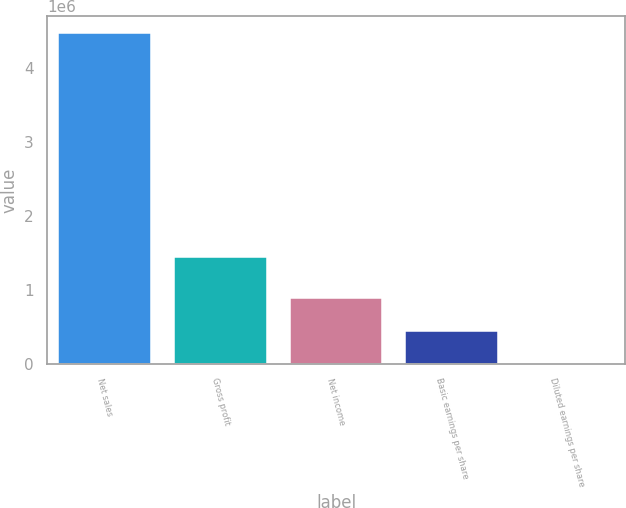Convert chart. <chart><loc_0><loc_0><loc_500><loc_500><bar_chart><fcel>Net sales<fcel>Gross profit<fcel>Net income<fcel>Basic earnings per share<fcel>Diluted earnings per share<nl><fcel>4.47454e+06<fcel>1.44091e+06<fcel>894908<fcel>447455<fcel>1.3<nl></chart> 